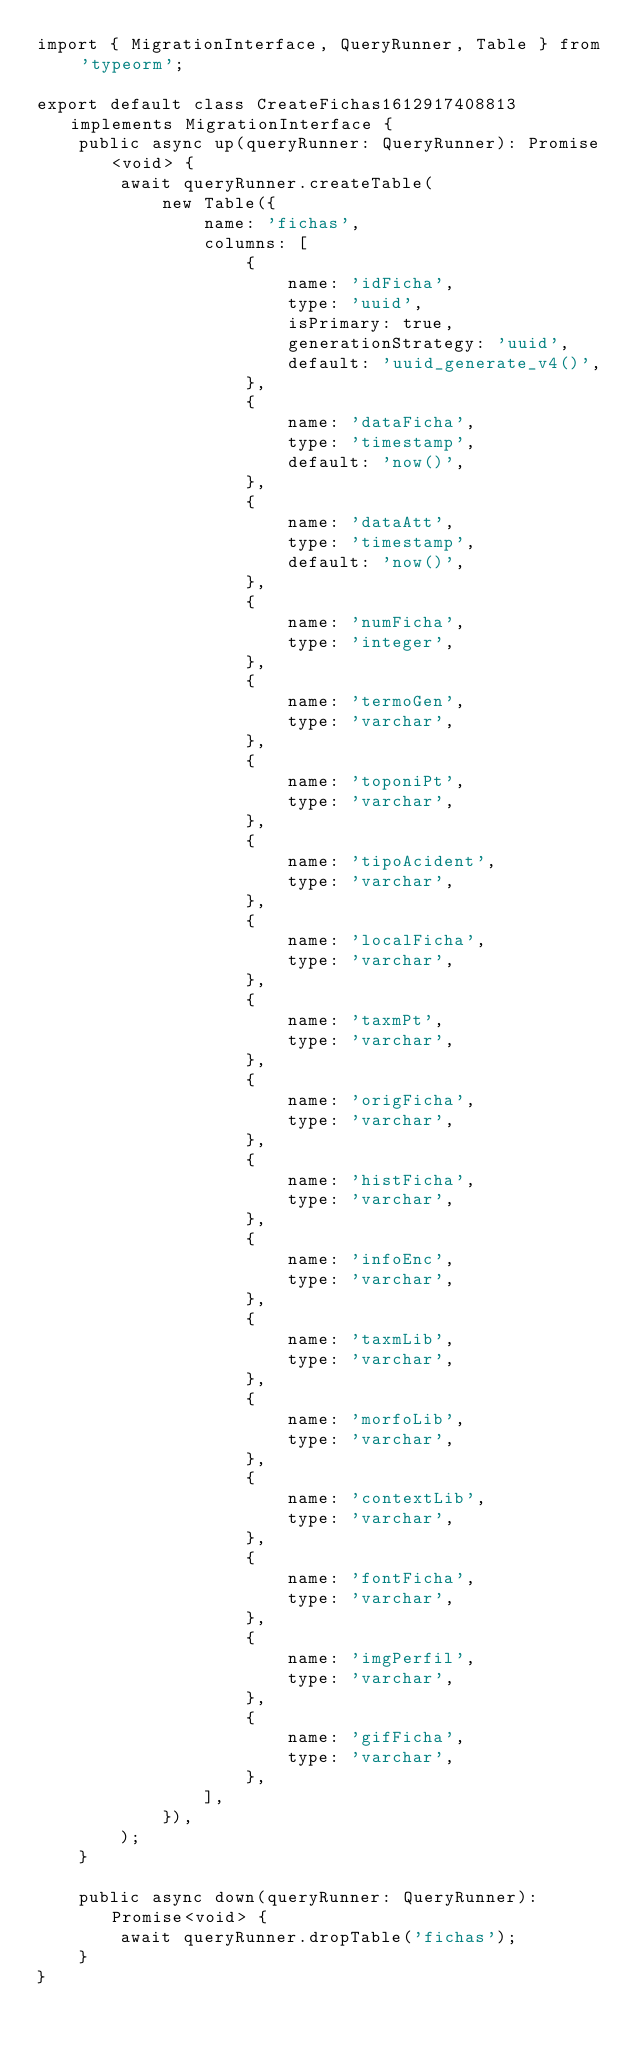Convert code to text. <code><loc_0><loc_0><loc_500><loc_500><_TypeScript_>import { MigrationInterface, QueryRunner, Table } from 'typeorm';

export default class CreateFichas1612917408813 implements MigrationInterface {
    public async up(queryRunner: QueryRunner): Promise<void> {
        await queryRunner.createTable(
            new Table({
                name: 'fichas',
                columns: [
                    {
                        name: 'idFicha',
                        type: 'uuid',
                        isPrimary: true,
                        generationStrategy: 'uuid',
                        default: 'uuid_generate_v4()',
                    },
                    {
                        name: 'dataFicha',
                        type: 'timestamp',
                        default: 'now()',
                    },
                    {
                        name: 'dataAtt',
                        type: 'timestamp',
                        default: 'now()',
                    },
                    {
                        name: 'numFicha',
                        type: 'integer',
                    },
                    {
                        name: 'termoGen',
                        type: 'varchar',
                    },
                    {
                        name: 'toponiPt',
                        type: 'varchar',
                    },
                    {
                        name: 'tipoAcident',
                        type: 'varchar',
                    },
                    {
                        name: 'localFicha',
                        type: 'varchar',
                    },
                    {
                        name: 'taxmPt',
                        type: 'varchar',
                    },
                    {
                        name: 'origFicha',
                        type: 'varchar',
                    },
                    {
                        name: 'histFicha',
                        type: 'varchar',
                    },
                    {
                        name: 'infoEnc',
                        type: 'varchar',
                    },
                    {
                        name: 'taxmLib',
                        type: 'varchar',
                    },
                    {
                        name: 'morfoLib',
                        type: 'varchar',
                    },
                    {
                        name: 'contextLib',
                        type: 'varchar',
                    },
                    {
                        name: 'fontFicha',
                        type: 'varchar',
                    },
                    {
                        name: 'imgPerfil',
                        type: 'varchar',
                    },
                    {
                        name: 'gifFicha',
                        type: 'varchar',
                    },
                ],
            }),
        );
    }

    public async down(queryRunner: QueryRunner): Promise<void> {
        await queryRunner.dropTable('fichas');
    }
}
</code> 